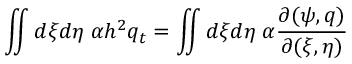<formula> <loc_0><loc_0><loc_500><loc_500>\iint d \xi d \eta \, \alpha h ^ { 2 } q _ { t } = \iint d \xi d \eta \, \alpha \frac { \partial ( \psi , q ) } { \partial ( \xi , \eta ) }</formula> 